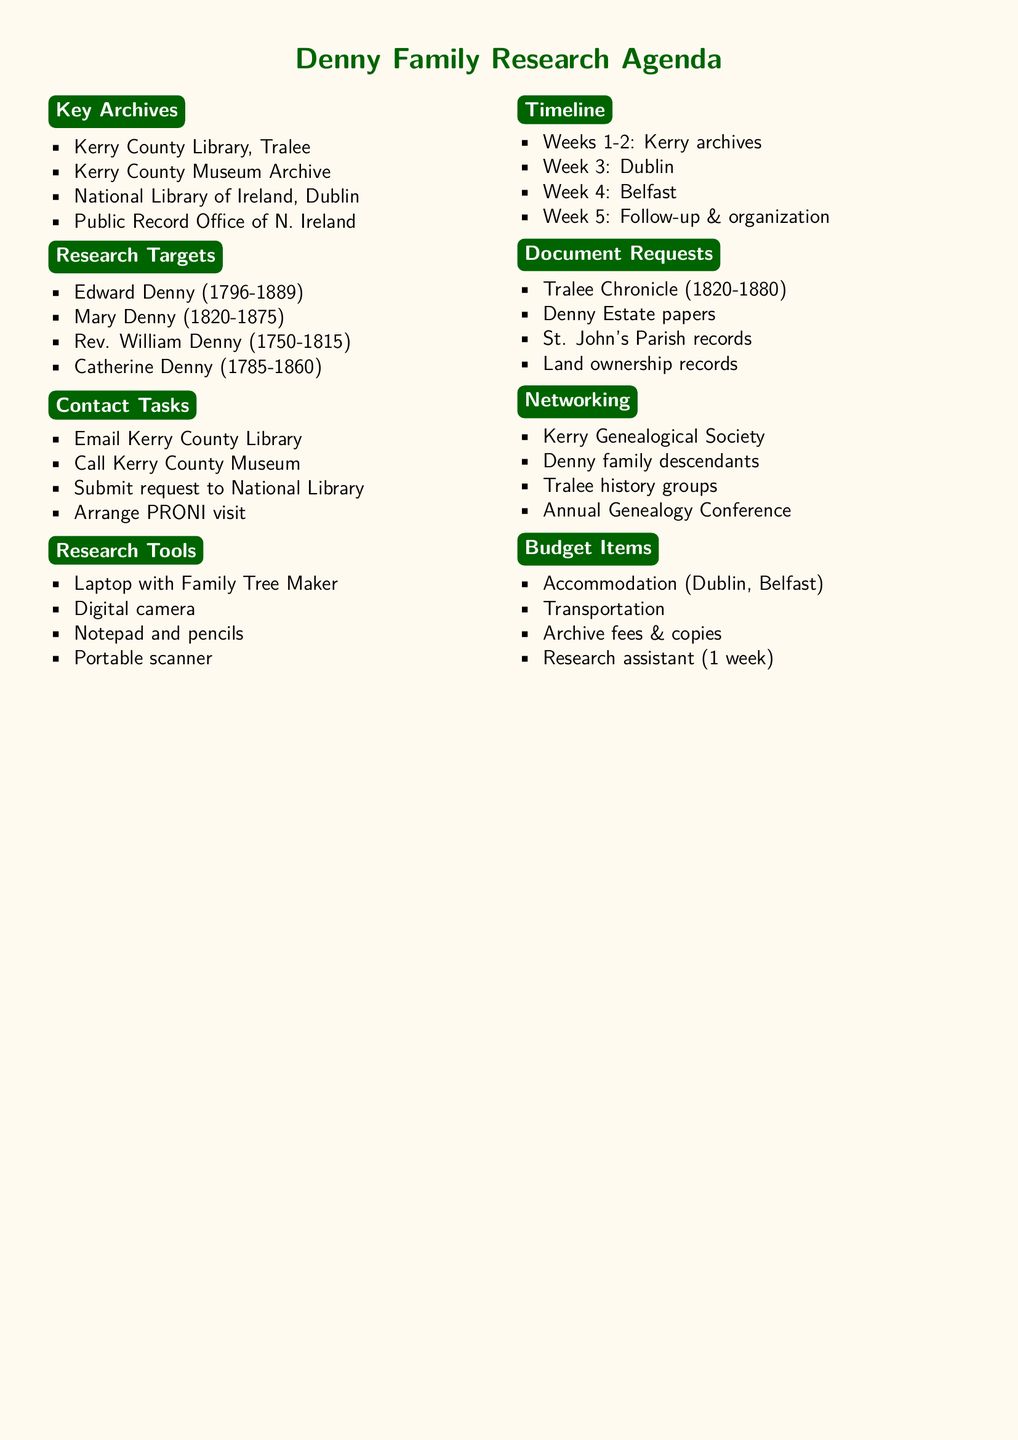What is the first archive mentioned in the document? The first archive listed under Key Archives is the Kerry County Library, Tralee.
Answer: Kerry County Library, Tralee Who is the philanthropist daughter of Anthony Denny? The document lists Mary Denny as the philanthropist daughter of Anthony Denny under Research Targets.
Answer: Mary Denny (1820-1875) How many weeks are allocated for research at the National Library of Ireland? The timeline specifies that one week is allocated for research at the National Library of Ireland, Dublin.
Answer: Week 3 What document request relates to church records? The document requests include church records from St. John's Parish, Tralee, under Specific Document Requests.
Answer: Church records from St. John's Parish, Tralee Which organization should be contacted for potential collaborations? The budget suggests contacting the Kerry Genealogical Society for networking opportunities.
Answer: Kerry Genealogical Society What type of tool is recommended for document reproduction? Under Preparing Research Tools, a digital camera is recommended for document reproduction.
Answer: Digital camera 